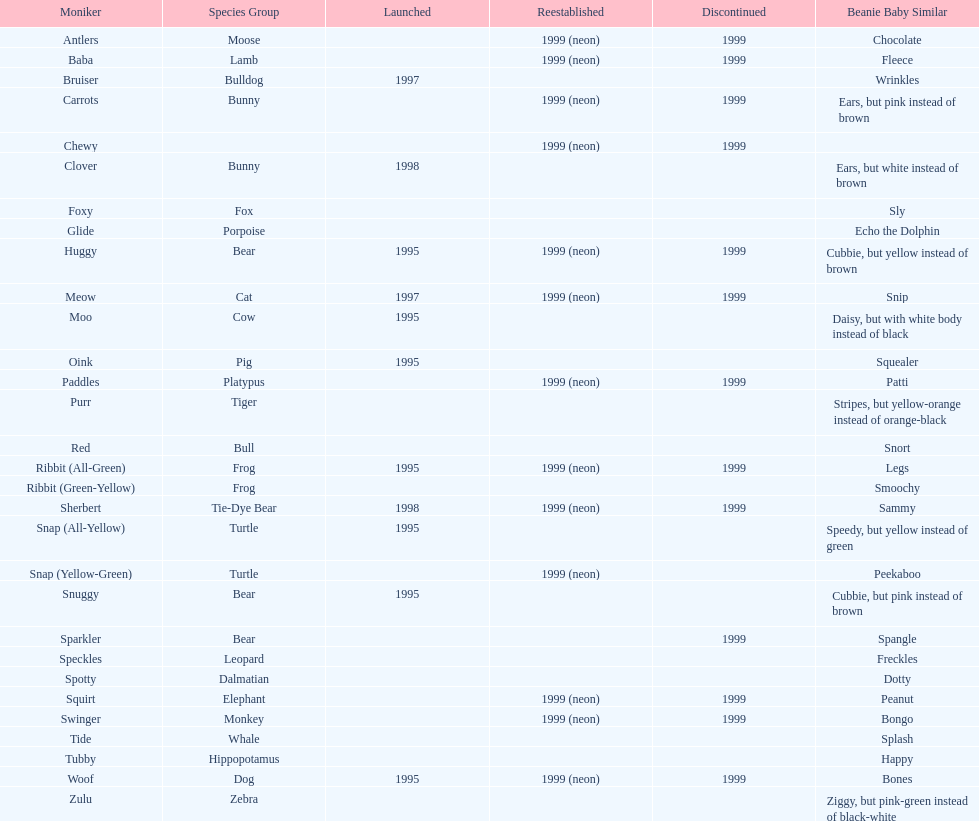Tell me the number of pillow pals reintroduced in 1999. 13. 